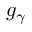<formula> <loc_0><loc_0><loc_500><loc_500>g _ { \gamma }</formula> 